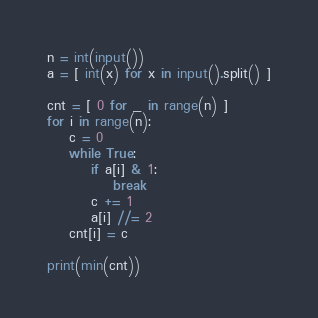Convert code to text. <code><loc_0><loc_0><loc_500><loc_500><_Python_>n = int(input())
a = [ int(x) for x in input().split() ]

cnt = [ 0 for _ in range(n) ]
for i in range(n):
    c = 0
    while True:
        if a[i] & 1:
            break
        c += 1
        a[i] //= 2
    cnt[i] = c

print(min(cnt))</code> 